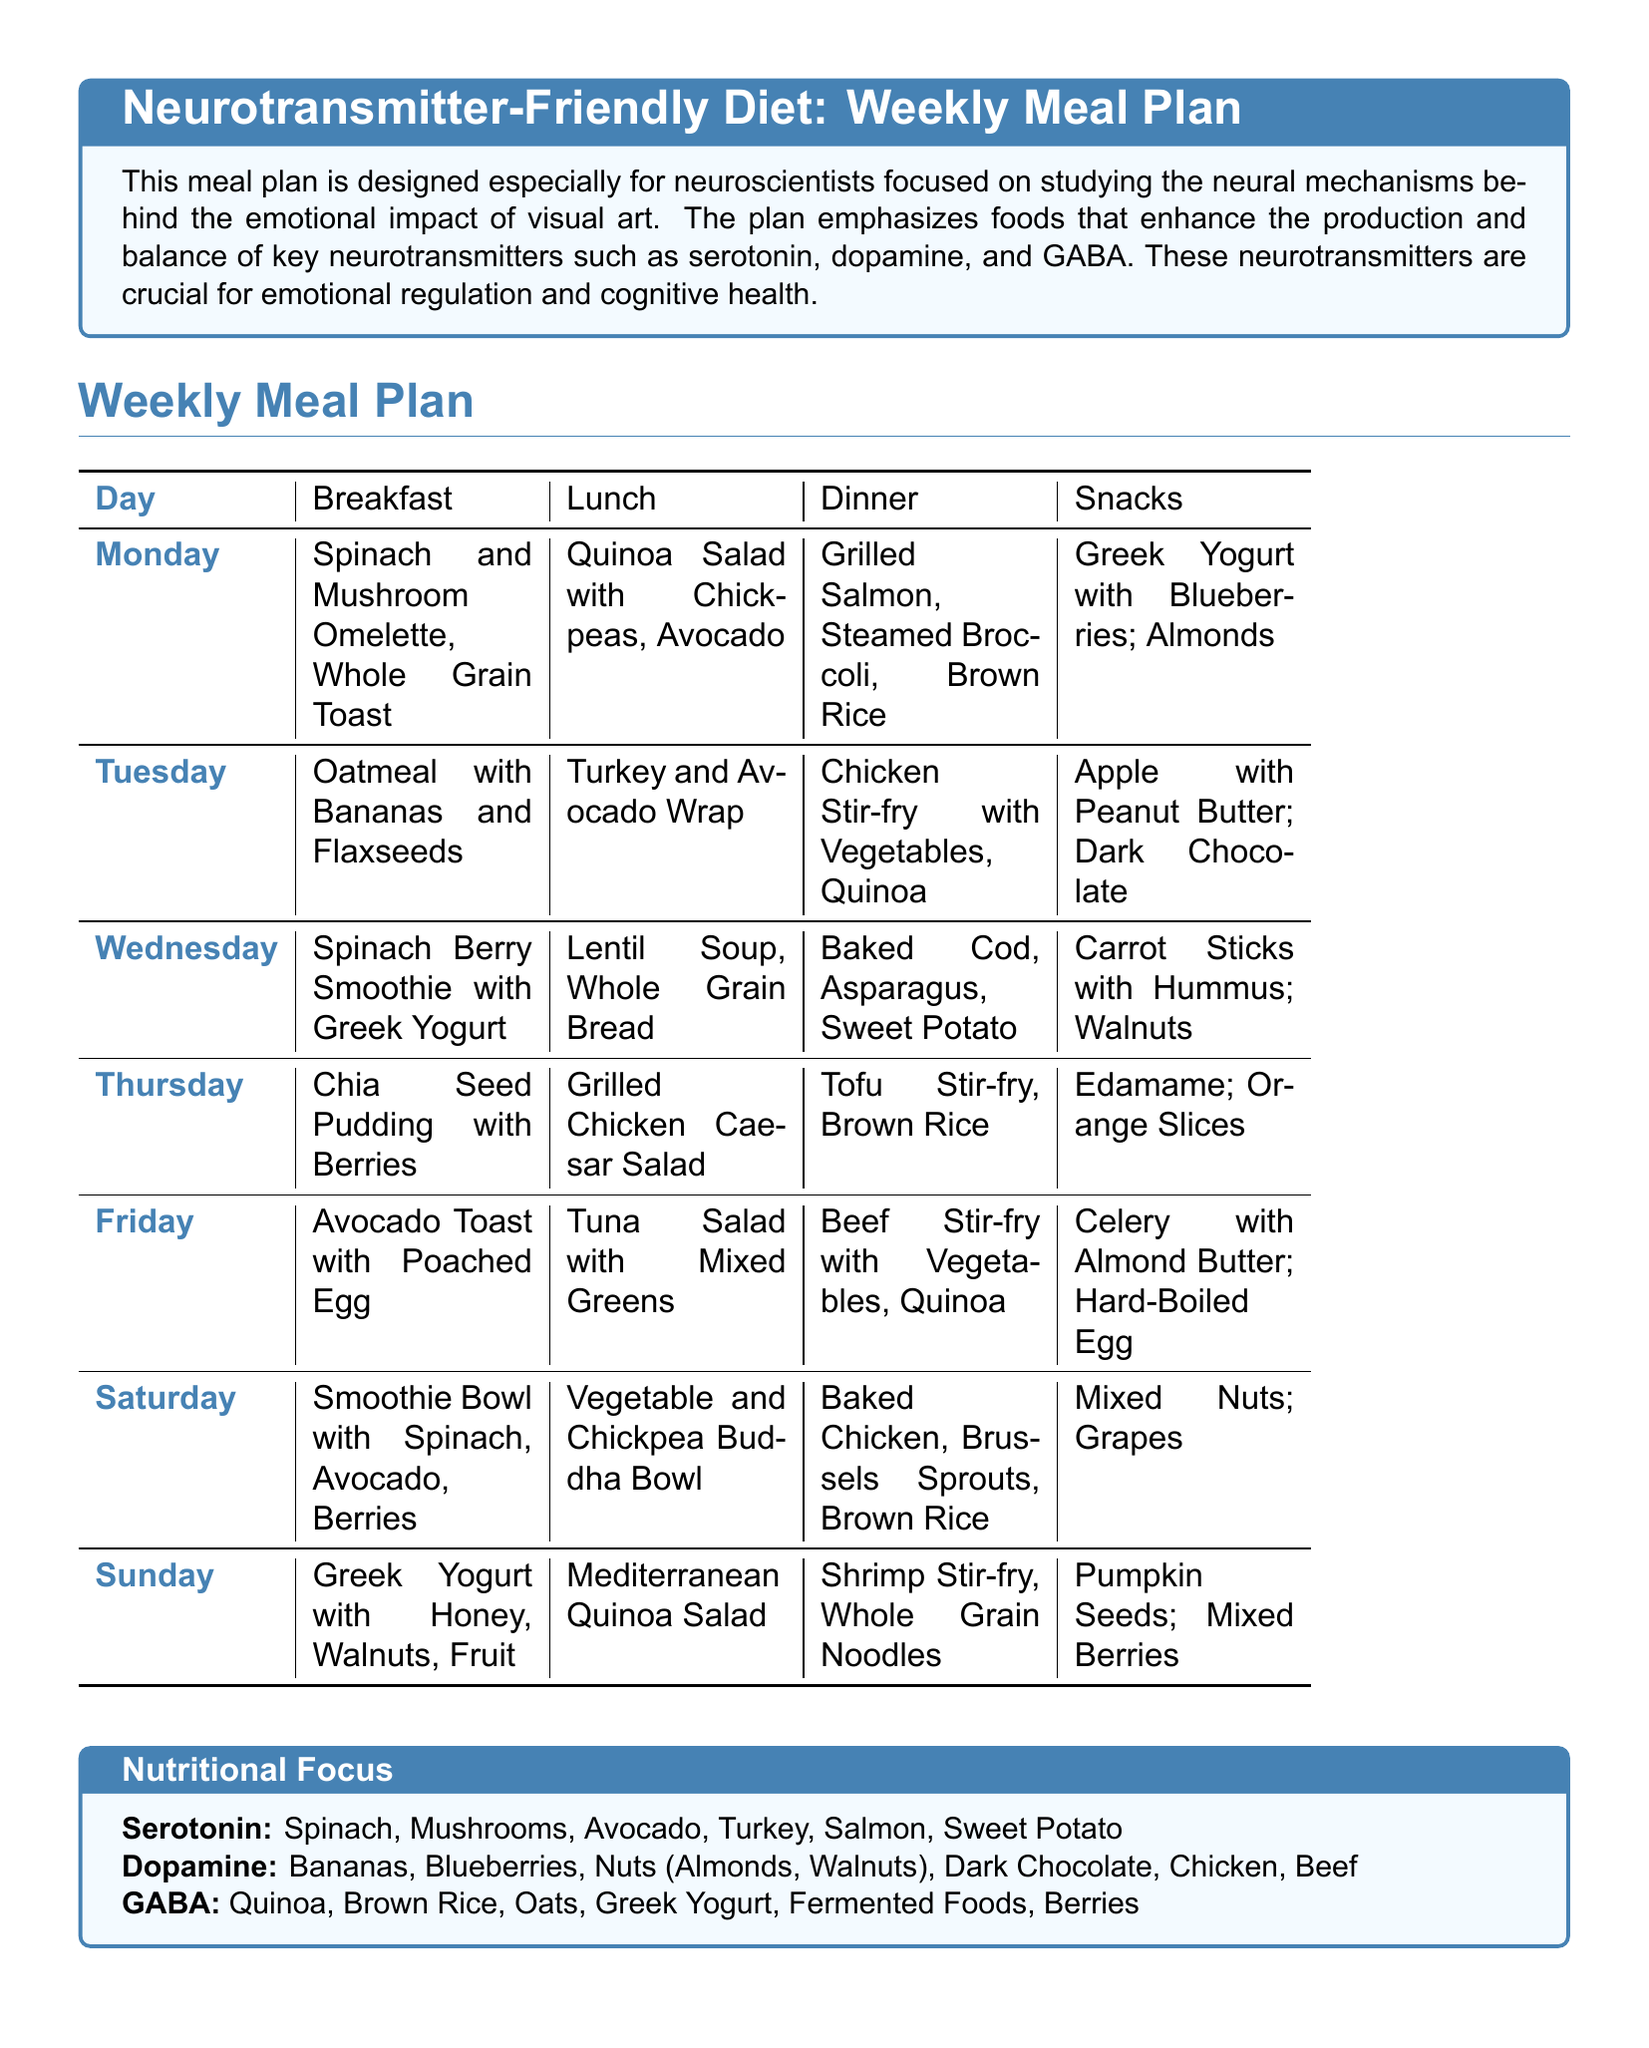what is the main focus of the meal plan? The main focus of the meal plan is on foods that support the production and balance of key neurotransmitters such as serotonin, dopamine, and GABA.
Answer: neurotransmitter production how many meals are included in the weekly meal plan? Each day of the meal plan includes four meals: breakfast, lunch, dinner, and snacks. Thus, there are a total of 28 meals in the weekly meal plan.
Answer: 28 meals which vegetable is mentioned for its role in serotonin production? Spinach is mentioned as a vegetable that supports serotonin production.
Answer: Spinach what kind of foods should be prioritized according to the key guidelines? The key guidelines suggest prioritizing whole foods over processed foods to maximize nutrient density.
Answer: Whole foods which fruit is noted for enhancing dopamine levels? Bananas are noted as a fruit that enhances dopamine levels.
Answer: Bananas what is a recommended snack option on Tuesday? On Tuesday, a recommended snack option is dark chocolate.
Answer: Dark chocolate how many days include a smoothie for breakfast? There are three days in the meal plan that include a smoothie for breakfast.
Answer: Three days which protein source appears most frequently in the weekly meal plan? Chicken appears most frequently in the weekly meal plan.
Answer: Chicken name one guideline for hydration suggested in the document. The document advises to stay hydrated with water and herbal teas.
Answer: Water and herbal teas 